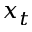Convert formula to latex. <formula><loc_0><loc_0><loc_500><loc_500>x _ { t }</formula> 